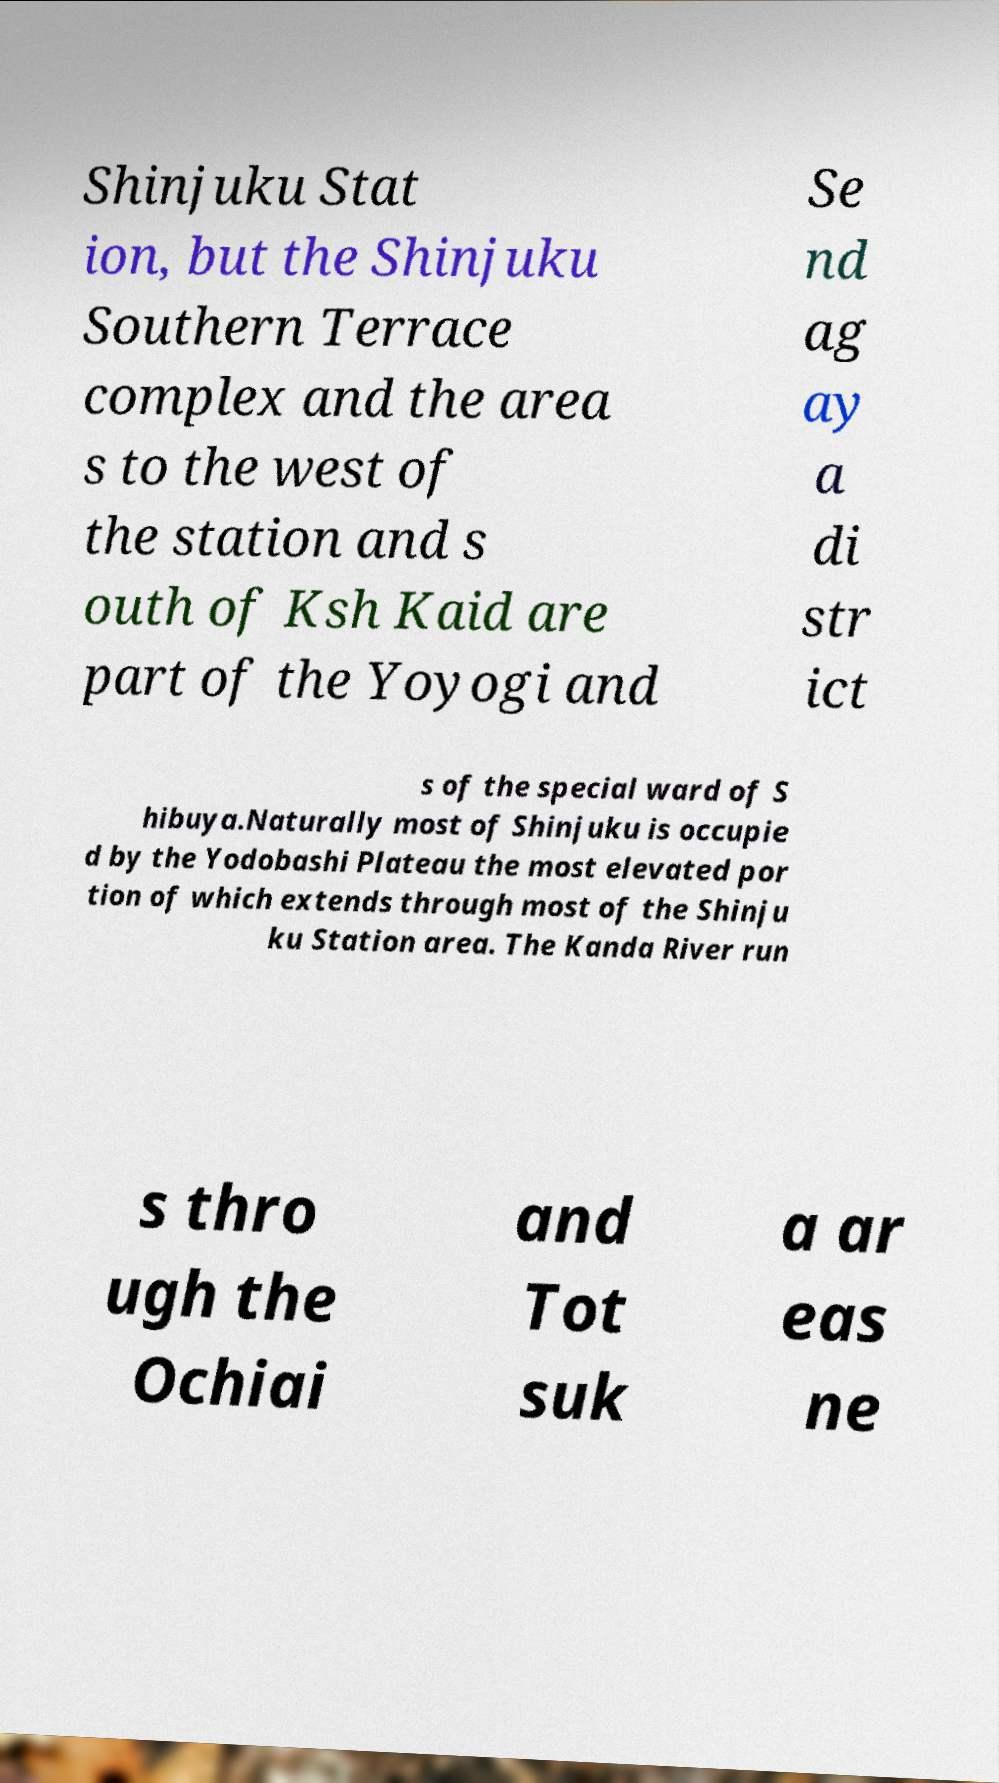For documentation purposes, I need the text within this image transcribed. Could you provide that? Shinjuku Stat ion, but the Shinjuku Southern Terrace complex and the area s to the west of the station and s outh of Ksh Kaid are part of the Yoyogi and Se nd ag ay a di str ict s of the special ward of S hibuya.Naturally most of Shinjuku is occupie d by the Yodobashi Plateau the most elevated por tion of which extends through most of the Shinju ku Station area. The Kanda River run s thro ugh the Ochiai and Tot suk a ar eas ne 